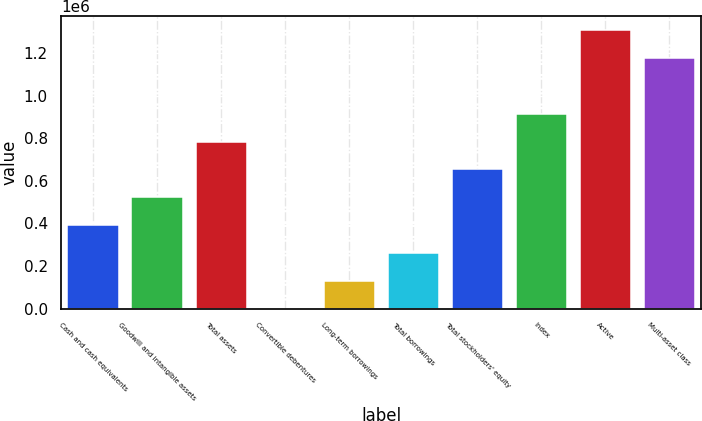Convert chart. <chart><loc_0><loc_0><loc_500><loc_500><bar_chart><fcel>Cash and cash equivalents<fcel>Goodwill and intangible assets<fcel>Total assets<fcel>Convertible debentures<fcel>Long-term borrowings<fcel>Total borrowings<fcel>Total stockholders' equity<fcel>Index<fcel>Active<fcel>Multi-asset class<nl><fcel>392317<fcel>523007<fcel>784389<fcel>245<fcel>130936<fcel>261626<fcel>653698<fcel>915079<fcel>1.30715e+06<fcel>1.17646e+06<nl></chart> 